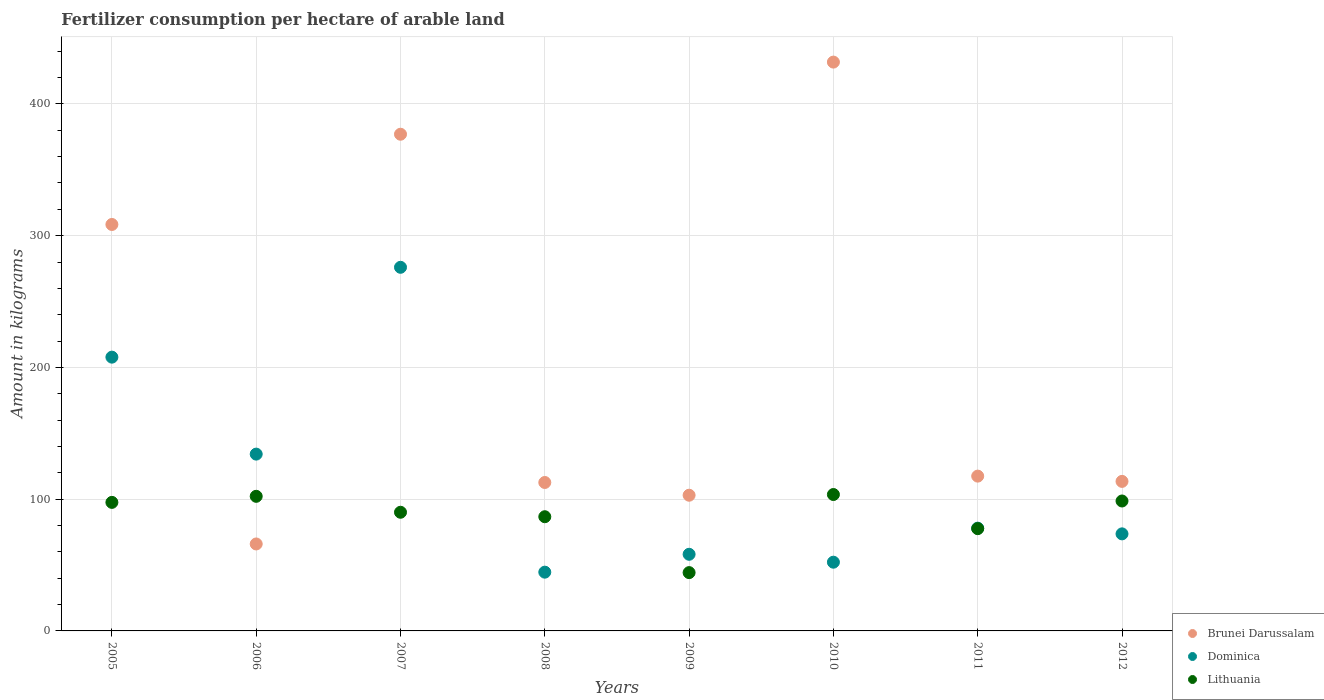How many different coloured dotlines are there?
Your answer should be compact. 3. What is the amount of fertilizer consumption in Lithuania in 2011?
Keep it short and to the point. 77.63. Across all years, what is the maximum amount of fertilizer consumption in Dominica?
Your response must be concise. 276. Across all years, what is the minimum amount of fertilizer consumption in Dominica?
Your answer should be very brief. 44.6. What is the total amount of fertilizer consumption in Brunei Darussalam in the graph?
Offer a terse response. 1629.92. What is the difference between the amount of fertilizer consumption in Brunei Darussalam in 2007 and that in 2011?
Make the answer very short. 259.5. What is the difference between the amount of fertilizer consumption in Lithuania in 2006 and the amount of fertilizer consumption in Brunei Darussalam in 2012?
Provide a succinct answer. -11.33. What is the average amount of fertilizer consumption in Dominica per year?
Give a very brief answer. 115.58. In the year 2006, what is the difference between the amount of fertilizer consumption in Dominica and amount of fertilizer consumption in Lithuania?
Your answer should be very brief. 32.03. What is the ratio of the amount of fertilizer consumption in Lithuania in 2007 to that in 2012?
Make the answer very short. 0.91. Is the difference between the amount of fertilizer consumption in Dominica in 2010 and 2012 greater than the difference between the amount of fertilizer consumption in Lithuania in 2010 and 2012?
Ensure brevity in your answer.  No. What is the difference between the highest and the second highest amount of fertilizer consumption in Dominica?
Ensure brevity in your answer.  68.2. What is the difference between the highest and the lowest amount of fertilizer consumption in Brunei Darussalam?
Ensure brevity in your answer.  365.75. Is the sum of the amount of fertilizer consumption in Lithuania in 2005 and 2009 greater than the maximum amount of fertilizer consumption in Brunei Darussalam across all years?
Offer a terse response. No. Does the amount of fertilizer consumption in Dominica monotonically increase over the years?
Keep it short and to the point. No. Is the amount of fertilizer consumption in Brunei Darussalam strictly less than the amount of fertilizer consumption in Lithuania over the years?
Provide a succinct answer. No. How many years are there in the graph?
Ensure brevity in your answer.  8. What is the difference between two consecutive major ticks on the Y-axis?
Offer a terse response. 100. Are the values on the major ticks of Y-axis written in scientific E-notation?
Keep it short and to the point. No. Does the graph contain any zero values?
Keep it short and to the point. No. Does the graph contain grids?
Give a very brief answer. Yes. Where does the legend appear in the graph?
Keep it short and to the point. Bottom right. How many legend labels are there?
Give a very brief answer. 3. How are the legend labels stacked?
Provide a short and direct response. Vertical. What is the title of the graph?
Offer a terse response. Fertilizer consumption per hectare of arable land. What is the label or title of the Y-axis?
Your response must be concise. Amount in kilograms. What is the Amount in kilograms in Brunei Darussalam in 2005?
Provide a short and direct response. 308.5. What is the Amount in kilograms in Dominica in 2005?
Make the answer very short. 207.8. What is the Amount in kilograms of Lithuania in 2005?
Give a very brief answer. 97.56. What is the Amount in kilograms of Brunei Darussalam in 2006?
Your answer should be compact. 66. What is the Amount in kilograms of Dominica in 2006?
Your answer should be compact. 134.2. What is the Amount in kilograms in Lithuania in 2006?
Keep it short and to the point. 102.17. What is the Amount in kilograms of Brunei Darussalam in 2007?
Your answer should be compact. 377. What is the Amount in kilograms of Dominica in 2007?
Provide a succinct answer. 276. What is the Amount in kilograms of Lithuania in 2007?
Your answer should be very brief. 90.07. What is the Amount in kilograms of Brunei Darussalam in 2008?
Ensure brevity in your answer.  112.67. What is the Amount in kilograms of Dominica in 2008?
Offer a very short reply. 44.6. What is the Amount in kilograms in Lithuania in 2008?
Provide a short and direct response. 86.68. What is the Amount in kilograms in Brunei Darussalam in 2009?
Make the answer very short. 103. What is the Amount in kilograms of Dominica in 2009?
Make the answer very short. 58.17. What is the Amount in kilograms in Lithuania in 2009?
Your answer should be very brief. 44.26. What is the Amount in kilograms of Brunei Darussalam in 2010?
Provide a succinct answer. 431.75. What is the Amount in kilograms in Dominica in 2010?
Your answer should be very brief. 52.17. What is the Amount in kilograms of Lithuania in 2010?
Keep it short and to the point. 103.53. What is the Amount in kilograms of Brunei Darussalam in 2011?
Keep it short and to the point. 117.5. What is the Amount in kilograms of Dominica in 2011?
Your response must be concise. 78. What is the Amount in kilograms of Lithuania in 2011?
Ensure brevity in your answer.  77.63. What is the Amount in kilograms in Brunei Darussalam in 2012?
Give a very brief answer. 113.5. What is the Amount in kilograms of Dominica in 2012?
Your response must be concise. 73.67. What is the Amount in kilograms of Lithuania in 2012?
Give a very brief answer. 98.62. Across all years, what is the maximum Amount in kilograms in Brunei Darussalam?
Offer a very short reply. 431.75. Across all years, what is the maximum Amount in kilograms of Dominica?
Keep it short and to the point. 276. Across all years, what is the maximum Amount in kilograms of Lithuania?
Keep it short and to the point. 103.53. Across all years, what is the minimum Amount in kilograms of Brunei Darussalam?
Provide a short and direct response. 66. Across all years, what is the minimum Amount in kilograms of Dominica?
Your response must be concise. 44.6. Across all years, what is the minimum Amount in kilograms in Lithuania?
Provide a succinct answer. 44.26. What is the total Amount in kilograms of Brunei Darussalam in the graph?
Offer a very short reply. 1629.92. What is the total Amount in kilograms in Dominica in the graph?
Your answer should be very brief. 924.6. What is the total Amount in kilograms in Lithuania in the graph?
Your response must be concise. 700.52. What is the difference between the Amount in kilograms of Brunei Darussalam in 2005 and that in 2006?
Your answer should be very brief. 242.5. What is the difference between the Amount in kilograms of Dominica in 2005 and that in 2006?
Make the answer very short. 73.6. What is the difference between the Amount in kilograms in Lithuania in 2005 and that in 2006?
Your answer should be very brief. -4.6. What is the difference between the Amount in kilograms of Brunei Darussalam in 2005 and that in 2007?
Provide a short and direct response. -68.5. What is the difference between the Amount in kilograms in Dominica in 2005 and that in 2007?
Your response must be concise. -68.2. What is the difference between the Amount in kilograms in Lithuania in 2005 and that in 2007?
Keep it short and to the point. 7.5. What is the difference between the Amount in kilograms in Brunei Darussalam in 2005 and that in 2008?
Provide a succinct answer. 195.83. What is the difference between the Amount in kilograms in Dominica in 2005 and that in 2008?
Your response must be concise. 163.2. What is the difference between the Amount in kilograms of Lithuania in 2005 and that in 2008?
Provide a short and direct response. 10.88. What is the difference between the Amount in kilograms of Brunei Darussalam in 2005 and that in 2009?
Provide a succinct answer. 205.5. What is the difference between the Amount in kilograms of Dominica in 2005 and that in 2009?
Give a very brief answer. 149.63. What is the difference between the Amount in kilograms of Lithuania in 2005 and that in 2009?
Your answer should be compact. 53.31. What is the difference between the Amount in kilograms of Brunei Darussalam in 2005 and that in 2010?
Offer a terse response. -123.25. What is the difference between the Amount in kilograms in Dominica in 2005 and that in 2010?
Your answer should be compact. 155.63. What is the difference between the Amount in kilograms of Lithuania in 2005 and that in 2010?
Offer a very short reply. -5.97. What is the difference between the Amount in kilograms of Brunei Darussalam in 2005 and that in 2011?
Offer a terse response. 191. What is the difference between the Amount in kilograms in Dominica in 2005 and that in 2011?
Provide a short and direct response. 129.8. What is the difference between the Amount in kilograms in Lithuania in 2005 and that in 2011?
Ensure brevity in your answer.  19.93. What is the difference between the Amount in kilograms in Brunei Darussalam in 2005 and that in 2012?
Give a very brief answer. 195. What is the difference between the Amount in kilograms in Dominica in 2005 and that in 2012?
Ensure brevity in your answer.  134.13. What is the difference between the Amount in kilograms in Lithuania in 2005 and that in 2012?
Your answer should be compact. -1.05. What is the difference between the Amount in kilograms in Brunei Darussalam in 2006 and that in 2007?
Your answer should be compact. -311. What is the difference between the Amount in kilograms of Dominica in 2006 and that in 2007?
Provide a succinct answer. -141.8. What is the difference between the Amount in kilograms in Lithuania in 2006 and that in 2007?
Ensure brevity in your answer.  12.1. What is the difference between the Amount in kilograms of Brunei Darussalam in 2006 and that in 2008?
Offer a very short reply. -46.67. What is the difference between the Amount in kilograms in Dominica in 2006 and that in 2008?
Your response must be concise. 89.6. What is the difference between the Amount in kilograms of Lithuania in 2006 and that in 2008?
Your answer should be compact. 15.49. What is the difference between the Amount in kilograms in Brunei Darussalam in 2006 and that in 2009?
Your answer should be very brief. -37. What is the difference between the Amount in kilograms in Dominica in 2006 and that in 2009?
Give a very brief answer. 76.03. What is the difference between the Amount in kilograms of Lithuania in 2006 and that in 2009?
Your answer should be very brief. 57.91. What is the difference between the Amount in kilograms of Brunei Darussalam in 2006 and that in 2010?
Give a very brief answer. -365.75. What is the difference between the Amount in kilograms in Dominica in 2006 and that in 2010?
Give a very brief answer. 82.03. What is the difference between the Amount in kilograms of Lithuania in 2006 and that in 2010?
Your answer should be compact. -1.37. What is the difference between the Amount in kilograms in Brunei Darussalam in 2006 and that in 2011?
Your answer should be compact. -51.5. What is the difference between the Amount in kilograms in Dominica in 2006 and that in 2011?
Your answer should be compact. 56.2. What is the difference between the Amount in kilograms in Lithuania in 2006 and that in 2011?
Give a very brief answer. 24.54. What is the difference between the Amount in kilograms in Brunei Darussalam in 2006 and that in 2012?
Your answer should be very brief. -47.5. What is the difference between the Amount in kilograms in Dominica in 2006 and that in 2012?
Offer a terse response. 60.53. What is the difference between the Amount in kilograms in Lithuania in 2006 and that in 2012?
Offer a very short reply. 3.55. What is the difference between the Amount in kilograms in Brunei Darussalam in 2007 and that in 2008?
Offer a terse response. 264.33. What is the difference between the Amount in kilograms in Dominica in 2007 and that in 2008?
Make the answer very short. 231.4. What is the difference between the Amount in kilograms of Lithuania in 2007 and that in 2008?
Your answer should be very brief. 3.38. What is the difference between the Amount in kilograms in Brunei Darussalam in 2007 and that in 2009?
Ensure brevity in your answer.  274. What is the difference between the Amount in kilograms in Dominica in 2007 and that in 2009?
Keep it short and to the point. 217.83. What is the difference between the Amount in kilograms in Lithuania in 2007 and that in 2009?
Provide a short and direct response. 45.81. What is the difference between the Amount in kilograms in Brunei Darussalam in 2007 and that in 2010?
Your response must be concise. -54.75. What is the difference between the Amount in kilograms of Dominica in 2007 and that in 2010?
Your response must be concise. 223.83. What is the difference between the Amount in kilograms of Lithuania in 2007 and that in 2010?
Your response must be concise. -13.47. What is the difference between the Amount in kilograms of Brunei Darussalam in 2007 and that in 2011?
Your answer should be very brief. 259.5. What is the difference between the Amount in kilograms of Dominica in 2007 and that in 2011?
Make the answer very short. 198. What is the difference between the Amount in kilograms in Lithuania in 2007 and that in 2011?
Make the answer very short. 12.43. What is the difference between the Amount in kilograms in Brunei Darussalam in 2007 and that in 2012?
Make the answer very short. 263.5. What is the difference between the Amount in kilograms in Dominica in 2007 and that in 2012?
Ensure brevity in your answer.  202.33. What is the difference between the Amount in kilograms of Lithuania in 2007 and that in 2012?
Make the answer very short. -8.55. What is the difference between the Amount in kilograms in Brunei Darussalam in 2008 and that in 2009?
Keep it short and to the point. 9.67. What is the difference between the Amount in kilograms in Dominica in 2008 and that in 2009?
Your response must be concise. -13.57. What is the difference between the Amount in kilograms of Lithuania in 2008 and that in 2009?
Your response must be concise. 42.43. What is the difference between the Amount in kilograms of Brunei Darussalam in 2008 and that in 2010?
Keep it short and to the point. -319.08. What is the difference between the Amount in kilograms of Dominica in 2008 and that in 2010?
Offer a very short reply. -7.57. What is the difference between the Amount in kilograms in Lithuania in 2008 and that in 2010?
Ensure brevity in your answer.  -16.85. What is the difference between the Amount in kilograms of Brunei Darussalam in 2008 and that in 2011?
Keep it short and to the point. -4.83. What is the difference between the Amount in kilograms of Dominica in 2008 and that in 2011?
Your response must be concise. -33.4. What is the difference between the Amount in kilograms of Lithuania in 2008 and that in 2011?
Your answer should be compact. 9.05. What is the difference between the Amount in kilograms of Dominica in 2008 and that in 2012?
Make the answer very short. -29.07. What is the difference between the Amount in kilograms in Lithuania in 2008 and that in 2012?
Make the answer very short. -11.94. What is the difference between the Amount in kilograms in Brunei Darussalam in 2009 and that in 2010?
Make the answer very short. -328.75. What is the difference between the Amount in kilograms in Lithuania in 2009 and that in 2010?
Your answer should be very brief. -59.28. What is the difference between the Amount in kilograms in Brunei Darussalam in 2009 and that in 2011?
Your response must be concise. -14.5. What is the difference between the Amount in kilograms of Dominica in 2009 and that in 2011?
Offer a terse response. -19.83. What is the difference between the Amount in kilograms of Lithuania in 2009 and that in 2011?
Provide a short and direct response. -33.38. What is the difference between the Amount in kilograms of Brunei Darussalam in 2009 and that in 2012?
Give a very brief answer. -10.5. What is the difference between the Amount in kilograms in Dominica in 2009 and that in 2012?
Your answer should be very brief. -15.5. What is the difference between the Amount in kilograms in Lithuania in 2009 and that in 2012?
Provide a succinct answer. -54.36. What is the difference between the Amount in kilograms in Brunei Darussalam in 2010 and that in 2011?
Your answer should be very brief. 314.25. What is the difference between the Amount in kilograms of Dominica in 2010 and that in 2011?
Offer a terse response. -25.83. What is the difference between the Amount in kilograms of Lithuania in 2010 and that in 2011?
Offer a terse response. 25.9. What is the difference between the Amount in kilograms of Brunei Darussalam in 2010 and that in 2012?
Your answer should be compact. 318.25. What is the difference between the Amount in kilograms of Dominica in 2010 and that in 2012?
Offer a terse response. -21.5. What is the difference between the Amount in kilograms in Lithuania in 2010 and that in 2012?
Your response must be concise. 4.92. What is the difference between the Amount in kilograms in Dominica in 2011 and that in 2012?
Your response must be concise. 4.33. What is the difference between the Amount in kilograms of Lithuania in 2011 and that in 2012?
Your answer should be compact. -20.98. What is the difference between the Amount in kilograms in Brunei Darussalam in 2005 and the Amount in kilograms in Dominica in 2006?
Your response must be concise. 174.3. What is the difference between the Amount in kilograms of Brunei Darussalam in 2005 and the Amount in kilograms of Lithuania in 2006?
Provide a short and direct response. 206.33. What is the difference between the Amount in kilograms in Dominica in 2005 and the Amount in kilograms in Lithuania in 2006?
Make the answer very short. 105.63. What is the difference between the Amount in kilograms in Brunei Darussalam in 2005 and the Amount in kilograms in Dominica in 2007?
Offer a terse response. 32.5. What is the difference between the Amount in kilograms in Brunei Darussalam in 2005 and the Amount in kilograms in Lithuania in 2007?
Your answer should be very brief. 218.43. What is the difference between the Amount in kilograms in Dominica in 2005 and the Amount in kilograms in Lithuania in 2007?
Your answer should be compact. 117.73. What is the difference between the Amount in kilograms in Brunei Darussalam in 2005 and the Amount in kilograms in Dominica in 2008?
Give a very brief answer. 263.9. What is the difference between the Amount in kilograms of Brunei Darussalam in 2005 and the Amount in kilograms of Lithuania in 2008?
Your response must be concise. 221.82. What is the difference between the Amount in kilograms in Dominica in 2005 and the Amount in kilograms in Lithuania in 2008?
Your response must be concise. 121.12. What is the difference between the Amount in kilograms of Brunei Darussalam in 2005 and the Amount in kilograms of Dominica in 2009?
Keep it short and to the point. 250.33. What is the difference between the Amount in kilograms of Brunei Darussalam in 2005 and the Amount in kilograms of Lithuania in 2009?
Ensure brevity in your answer.  264.24. What is the difference between the Amount in kilograms in Dominica in 2005 and the Amount in kilograms in Lithuania in 2009?
Your answer should be compact. 163.54. What is the difference between the Amount in kilograms in Brunei Darussalam in 2005 and the Amount in kilograms in Dominica in 2010?
Your response must be concise. 256.33. What is the difference between the Amount in kilograms in Brunei Darussalam in 2005 and the Amount in kilograms in Lithuania in 2010?
Your answer should be compact. 204.97. What is the difference between the Amount in kilograms of Dominica in 2005 and the Amount in kilograms of Lithuania in 2010?
Your response must be concise. 104.27. What is the difference between the Amount in kilograms of Brunei Darussalam in 2005 and the Amount in kilograms of Dominica in 2011?
Your answer should be compact. 230.5. What is the difference between the Amount in kilograms of Brunei Darussalam in 2005 and the Amount in kilograms of Lithuania in 2011?
Ensure brevity in your answer.  230.87. What is the difference between the Amount in kilograms in Dominica in 2005 and the Amount in kilograms in Lithuania in 2011?
Your answer should be very brief. 130.17. What is the difference between the Amount in kilograms of Brunei Darussalam in 2005 and the Amount in kilograms of Dominica in 2012?
Provide a short and direct response. 234.83. What is the difference between the Amount in kilograms of Brunei Darussalam in 2005 and the Amount in kilograms of Lithuania in 2012?
Provide a short and direct response. 209.88. What is the difference between the Amount in kilograms in Dominica in 2005 and the Amount in kilograms in Lithuania in 2012?
Offer a very short reply. 109.18. What is the difference between the Amount in kilograms of Brunei Darussalam in 2006 and the Amount in kilograms of Dominica in 2007?
Keep it short and to the point. -210. What is the difference between the Amount in kilograms of Brunei Darussalam in 2006 and the Amount in kilograms of Lithuania in 2007?
Offer a very short reply. -24.07. What is the difference between the Amount in kilograms in Dominica in 2006 and the Amount in kilograms in Lithuania in 2007?
Offer a terse response. 44.13. What is the difference between the Amount in kilograms in Brunei Darussalam in 2006 and the Amount in kilograms in Dominica in 2008?
Provide a short and direct response. 21.4. What is the difference between the Amount in kilograms of Brunei Darussalam in 2006 and the Amount in kilograms of Lithuania in 2008?
Offer a terse response. -20.68. What is the difference between the Amount in kilograms in Dominica in 2006 and the Amount in kilograms in Lithuania in 2008?
Provide a short and direct response. 47.52. What is the difference between the Amount in kilograms of Brunei Darussalam in 2006 and the Amount in kilograms of Dominica in 2009?
Keep it short and to the point. 7.83. What is the difference between the Amount in kilograms in Brunei Darussalam in 2006 and the Amount in kilograms in Lithuania in 2009?
Give a very brief answer. 21.74. What is the difference between the Amount in kilograms of Dominica in 2006 and the Amount in kilograms of Lithuania in 2009?
Give a very brief answer. 89.94. What is the difference between the Amount in kilograms in Brunei Darussalam in 2006 and the Amount in kilograms in Dominica in 2010?
Keep it short and to the point. 13.83. What is the difference between the Amount in kilograms of Brunei Darussalam in 2006 and the Amount in kilograms of Lithuania in 2010?
Give a very brief answer. -37.53. What is the difference between the Amount in kilograms in Dominica in 2006 and the Amount in kilograms in Lithuania in 2010?
Your answer should be very brief. 30.67. What is the difference between the Amount in kilograms of Brunei Darussalam in 2006 and the Amount in kilograms of Lithuania in 2011?
Your answer should be compact. -11.63. What is the difference between the Amount in kilograms of Dominica in 2006 and the Amount in kilograms of Lithuania in 2011?
Provide a short and direct response. 56.57. What is the difference between the Amount in kilograms of Brunei Darussalam in 2006 and the Amount in kilograms of Dominica in 2012?
Provide a short and direct response. -7.67. What is the difference between the Amount in kilograms of Brunei Darussalam in 2006 and the Amount in kilograms of Lithuania in 2012?
Your answer should be compact. -32.62. What is the difference between the Amount in kilograms in Dominica in 2006 and the Amount in kilograms in Lithuania in 2012?
Make the answer very short. 35.58. What is the difference between the Amount in kilograms of Brunei Darussalam in 2007 and the Amount in kilograms of Dominica in 2008?
Provide a succinct answer. 332.4. What is the difference between the Amount in kilograms of Brunei Darussalam in 2007 and the Amount in kilograms of Lithuania in 2008?
Your response must be concise. 290.32. What is the difference between the Amount in kilograms in Dominica in 2007 and the Amount in kilograms in Lithuania in 2008?
Offer a very short reply. 189.32. What is the difference between the Amount in kilograms of Brunei Darussalam in 2007 and the Amount in kilograms of Dominica in 2009?
Ensure brevity in your answer.  318.83. What is the difference between the Amount in kilograms in Brunei Darussalam in 2007 and the Amount in kilograms in Lithuania in 2009?
Give a very brief answer. 332.74. What is the difference between the Amount in kilograms in Dominica in 2007 and the Amount in kilograms in Lithuania in 2009?
Your answer should be very brief. 231.74. What is the difference between the Amount in kilograms in Brunei Darussalam in 2007 and the Amount in kilograms in Dominica in 2010?
Your response must be concise. 324.83. What is the difference between the Amount in kilograms of Brunei Darussalam in 2007 and the Amount in kilograms of Lithuania in 2010?
Offer a very short reply. 273.47. What is the difference between the Amount in kilograms in Dominica in 2007 and the Amount in kilograms in Lithuania in 2010?
Offer a terse response. 172.47. What is the difference between the Amount in kilograms in Brunei Darussalam in 2007 and the Amount in kilograms in Dominica in 2011?
Your answer should be very brief. 299. What is the difference between the Amount in kilograms of Brunei Darussalam in 2007 and the Amount in kilograms of Lithuania in 2011?
Provide a short and direct response. 299.37. What is the difference between the Amount in kilograms in Dominica in 2007 and the Amount in kilograms in Lithuania in 2011?
Make the answer very short. 198.37. What is the difference between the Amount in kilograms in Brunei Darussalam in 2007 and the Amount in kilograms in Dominica in 2012?
Give a very brief answer. 303.33. What is the difference between the Amount in kilograms in Brunei Darussalam in 2007 and the Amount in kilograms in Lithuania in 2012?
Ensure brevity in your answer.  278.38. What is the difference between the Amount in kilograms in Dominica in 2007 and the Amount in kilograms in Lithuania in 2012?
Provide a short and direct response. 177.38. What is the difference between the Amount in kilograms of Brunei Darussalam in 2008 and the Amount in kilograms of Dominica in 2009?
Offer a very short reply. 54.5. What is the difference between the Amount in kilograms of Brunei Darussalam in 2008 and the Amount in kilograms of Lithuania in 2009?
Provide a succinct answer. 68.41. What is the difference between the Amount in kilograms of Dominica in 2008 and the Amount in kilograms of Lithuania in 2009?
Your answer should be compact. 0.34. What is the difference between the Amount in kilograms of Brunei Darussalam in 2008 and the Amount in kilograms of Dominica in 2010?
Your answer should be very brief. 60.5. What is the difference between the Amount in kilograms of Brunei Darussalam in 2008 and the Amount in kilograms of Lithuania in 2010?
Your answer should be very brief. 9.13. What is the difference between the Amount in kilograms of Dominica in 2008 and the Amount in kilograms of Lithuania in 2010?
Your response must be concise. -58.93. What is the difference between the Amount in kilograms in Brunei Darussalam in 2008 and the Amount in kilograms in Dominica in 2011?
Your answer should be very brief. 34.67. What is the difference between the Amount in kilograms of Brunei Darussalam in 2008 and the Amount in kilograms of Lithuania in 2011?
Offer a terse response. 35.03. What is the difference between the Amount in kilograms of Dominica in 2008 and the Amount in kilograms of Lithuania in 2011?
Ensure brevity in your answer.  -33.03. What is the difference between the Amount in kilograms of Brunei Darussalam in 2008 and the Amount in kilograms of Lithuania in 2012?
Make the answer very short. 14.05. What is the difference between the Amount in kilograms in Dominica in 2008 and the Amount in kilograms in Lithuania in 2012?
Offer a very short reply. -54.02. What is the difference between the Amount in kilograms in Brunei Darussalam in 2009 and the Amount in kilograms in Dominica in 2010?
Ensure brevity in your answer.  50.83. What is the difference between the Amount in kilograms in Brunei Darussalam in 2009 and the Amount in kilograms in Lithuania in 2010?
Your answer should be very brief. -0.53. What is the difference between the Amount in kilograms of Dominica in 2009 and the Amount in kilograms of Lithuania in 2010?
Provide a short and direct response. -45.37. What is the difference between the Amount in kilograms in Brunei Darussalam in 2009 and the Amount in kilograms in Lithuania in 2011?
Keep it short and to the point. 25.37. What is the difference between the Amount in kilograms of Dominica in 2009 and the Amount in kilograms of Lithuania in 2011?
Keep it short and to the point. -19.47. What is the difference between the Amount in kilograms of Brunei Darussalam in 2009 and the Amount in kilograms of Dominica in 2012?
Offer a terse response. 29.33. What is the difference between the Amount in kilograms in Brunei Darussalam in 2009 and the Amount in kilograms in Lithuania in 2012?
Your answer should be very brief. 4.38. What is the difference between the Amount in kilograms of Dominica in 2009 and the Amount in kilograms of Lithuania in 2012?
Make the answer very short. -40.45. What is the difference between the Amount in kilograms of Brunei Darussalam in 2010 and the Amount in kilograms of Dominica in 2011?
Ensure brevity in your answer.  353.75. What is the difference between the Amount in kilograms of Brunei Darussalam in 2010 and the Amount in kilograms of Lithuania in 2011?
Provide a succinct answer. 354.12. What is the difference between the Amount in kilograms of Dominica in 2010 and the Amount in kilograms of Lithuania in 2011?
Your answer should be compact. -25.47. What is the difference between the Amount in kilograms of Brunei Darussalam in 2010 and the Amount in kilograms of Dominica in 2012?
Provide a succinct answer. 358.08. What is the difference between the Amount in kilograms in Brunei Darussalam in 2010 and the Amount in kilograms in Lithuania in 2012?
Make the answer very short. 333.13. What is the difference between the Amount in kilograms of Dominica in 2010 and the Amount in kilograms of Lithuania in 2012?
Offer a very short reply. -46.45. What is the difference between the Amount in kilograms of Brunei Darussalam in 2011 and the Amount in kilograms of Dominica in 2012?
Provide a short and direct response. 43.83. What is the difference between the Amount in kilograms of Brunei Darussalam in 2011 and the Amount in kilograms of Lithuania in 2012?
Your response must be concise. 18.88. What is the difference between the Amount in kilograms in Dominica in 2011 and the Amount in kilograms in Lithuania in 2012?
Your response must be concise. -20.62. What is the average Amount in kilograms of Brunei Darussalam per year?
Your answer should be compact. 203.74. What is the average Amount in kilograms in Dominica per year?
Make the answer very short. 115.58. What is the average Amount in kilograms in Lithuania per year?
Your response must be concise. 87.56. In the year 2005, what is the difference between the Amount in kilograms in Brunei Darussalam and Amount in kilograms in Dominica?
Ensure brevity in your answer.  100.7. In the year 2005, what is the difference between the Amount in kilograms of Brunei Darussalam and Amount in kilograms of Lithuania?
Give a very brief answer. 210.94. In the year 2005, what is the difference between the Amount in kilograms of Dominica and Amount in kilograms of Lithuania?
Make the answer very short. 110.24. In the year 2006, what is the difference between the Amount in kilograms in Brunei Darussalam and Amount in kilograms in Dominica?
Offer a terse response. -68.2. In the year 2006, what is the difference between the Amount in kilograms of Brunei Darussalam and Amount in kilograms of Lithuania?
Your response must be concise. -36.17. In the year 2006, what is the difference between the Amount in kilograms of Dominica and Amount in kilograms of Lithuania?
Make the answer very short. 32.03. In the year 2007, what is the difference between the Amount in kilograms in Brunei Darussalam and Amount in kilograms in Dominica?
Provide a short and direct response. 101. In the year 2007, what is the difference between the Amount in kilograms of Brunei Darussalam and Amount in kilograms of Lithuania?
Make the answer very short. 286.93. In the year 2007, what is the difference between the Amount in kilograms in Dominica and Amount in kilograms in Lithuania?
Offer a terse response. 185.93. In the year 2008, what is the difference between the Amount in kilograms of Brunei Darussalam and Amount in kilograms of Dominica?
Your answer should be very brief. 68.07. In the year 2008, what is the difference between the Amount in kilograms in Brunei Darussalam and Amount in kilograms in Lithuania?
Your answer should be compact. 25.99. In the year 2008, what is the difference between the Amount in kilograms of Dominica and Amount in kilograms of Lithuania?
Your answer should be compact. -42.08. In the year 2009, what is the difference between the Amount in kilograms in Brunei Darussalam and Amount in kilograms in Dominica?
Your answer should be compact. 44.83. In the year 2009, what is the difference between the Amount in kilograms in Brunei Darussalam and Amount in kilograms in Lithuania?
Make the answer very short. 58.74. In the year 2009, what is the difference between the Amount in kilograms of Dominica and Amount in kilograms of Lithuania?
Offer a terse response. 13.91. In the year 2010, what is the difference between the Amount in kilograms in Brunei Darussalam and Amount in kilograms in Dominica?
Give a very brief answer. 379.58. In the year 2010, what is the difference between the Amount in kilograms in Brunei Darussalam and Amount in kilograms in Lithuania?
Provide a succinct answer. 328.22. In the year 2010, what is the difference between the Amount in kilograms in Dominica and Amount in kilograms in Lithuania?
Your response must be concise. -51.37. In the year 2011, what is the difference between the Amount in kilograms of Brunei Darussalam and Amount in kilograms of Dominica?
Ensure brevity in your answer.  39.5. In the year 2011, what is the difference between the Amount in kilograms in Brunei Darussalam and Amount in kilograms in Lithuania?
Offer a very short reply. 39.87. In the year 2011, what is the difference between the Amount in kilograms in Dominica and Amount in kilograms in Lithuania?
Keep it short and to the point. 0.37. In the year 2012, what is the difference between the Amount in kilograms of Brunei Darussalam and Amount in kilograms of Dominica?
Keep it short and to the point. 39.83. In the year 2012, what is the difference between the Amount in kilograms of Brunei Darussalam and Amount in kilograms of Lithuania?
Provide a short and direct response. 14.88. In the year 2012, what is the difference between the Amount in kilograms in Dominica and Amount in kilograms in Lithuania?
Your response must be concise. -24.95. What is the ratio of the Amount in kilograms of Brunei Darussalam in 2005 to that in 2006?
Provide a succinct answer. 4.67. What is the ratio of the Amount in kilograms of Dominica in 2005 to that in 2006?
Make the answer very short. 1.55. What is the ratio of the Amount in kilograms in Lithuania in 2005 to that in 2006?
Keep it short and to the point. 0.95. What is the ratio of the Amount in kilograms of Brunei Darussalam in 2005 to that in 2007?
Your answer should be very brief. 0.82. What is the ratio of the Amount in kilograms of Dominica in 2005 to that in 2007?
Make the answer very short. 0.75. What is the ratio of the Amount in kilograms of Brunei Darussalam in 2005 to that in 2008?
Offer a very short reply. 2.74. What is the ratio of the Amount in kilograms of Dominica in 2005 to that in 2008?
Ensure brevity in your answer.  4.66. What is the ratio of the Amount in kilograms in Lithuania in 2005 to that in 2008?
Your response must be concise. 1.13. What is the ratio of the Amount in kilograms in Brunei Darussalam in 2005 to that in 2009?
Provide a short and direct response. 3. What is the ratio of the Amount in kilograms of Dominica in 2005 to that in 2009?
Give a very brief answer. 3.57. What is the ratio of the Amount in kilograms of Lithuania in 2005 to that in 2009?
Make the answer very short. 2.2. What is the ratio of the Amount in kilograms in Brunei Darussalam in 2005 to that in 2010?
Your answer should be compact. 0.71. What is the ratio of the Amount in kilograms of Dominica in 2005 to that in 2010?
Your response must be concise. 3.98. What is the ratio of the Amount in kilograms of Lithuania in 2005 to that in 2010?
Keep it short and to the point. 0.94. What is the ratio of the Amount in kilograms in Brunei Darussalam in 2005 to that in 2011?
Your answer should be compact. 2.63. What is the ratio of the Amount in kilograms of Dominica in 2005 to that in 2011?
Offer a very short reply. 2.66. What is the ratio of the Amount in kilograms of Lithuania in 2005 to that in 2011?
Offer a terse response. 1.26. What is the ratio of the Amount in kilograms in Brunei Darussalam in 2005 to that in 2012?
Provide a short and direct response. 2.72. What is the ratio of the Amount in kilograms in Dominica in 2005 to that in 2012?
Your answer should be very brief. 2.82. What is the ratio of the Amount in kilograms in Lithuania in 2005 to that in 2012?
Your answer should be compact. 0.99. What is the ratio of the Amount in kilograms in Brunei Darussalam in 2006 to that in 2007?
Your response must be concise. 0.18. What is the ratio of the Amount in kilograms of Dominica in 2006 to that in 2007?
Make the answer very short. 0.49. What is the ratio of the Amount in kilograms in Lithuania in 2006 to that in 2007?
Keep it short and to the point. 1.13. What is the ratio of the Amount in kilograms of Brunei Darussalam in 2006 to that in 2008?
Keep it short and to the point. 0.59. What is the ratio of the Amount in kilograms in Dominica in 2006 to that in 2008?
Provide a short and direct response. 3.01. What is the ratio of the Amount in kilograms in Lithuania in 2006 to that in 2008?
Provide a succinct answer. 1.18. What is the ratio of the Amount in kilograms of Brunei Darussalam in 2006 to that in 2009?
Give a very brief answer. 0.64. What is the ratio of the Amount in kilograms in Dominica in 2006 to that in 2009?
Ensure brevity in your answer.  2.31. What is the ratio of the Amount in kilograms in Lithuania in 2006 to that in 2009?
Give a very brief answer. 2.31. What is the ratio of the Amount in kilograms in Brunei Darussalam in 2006 to that in 2010?
Give a very brief answer. 0.15. What is the ratio of the Amount in kilograms in Dominica in 2006 to that in 2010?
Provide a short and direct response. 2.57. What is the ratio of the Amount in kilograms in Brunei Darussalam in 2006 to that in 2011?
Provide a short and direct response. 0.56. What is the ratio of the Amount in kilograms in Dominica in 2006 to that in 2011?
Keep it short and to the point. 1.72. What is the ratio of the Amount in kilograms of Lithuania in 2006 to that in 2011?
Offer a very short reply. 1.32. What is the ratio of the Amount in kilograms in Brunei Darussalam in 2006 to that in 2012?
Your answer should be very brief. 0.58. What is the ratio of the Amount in kilograms in Dominica in 2006 to that in 2012?
Give a very brief answer. 1.82. What is the ratio of the Amount in kilograms of Lithuania in 2006 to that in 2012?
Keep it short and to the point. 1.04. What is the ratio of the Amount in kilograms of Brunei Darussalam in 2007 to that in 2008?
Offer a terse response. 3.35. What is the ratio of the Amount in kilograms in Dominica in 2007 to that in 2008?
Give a very brief answer. 6.19. What is the ratio of the Amount in kilograms in Lithuania in 2007 to that in 2008?
Provide a short and direct response. 1.04. What is the ratio of the Amount in kilograms in Brunei Darussalam in 2007 to that in 2009?
Keep it short and to the point. 3.66. What is the ratio of the Amount in kilograms in Dominica in 2007 to that in 2009?
Keep it short and to the point. 4.75. What is the ratio of the Amount in kilograms of Lithuania in 2007 to that in 2009?
Make the answer very short. 2.04. What is the ratio of the Amount in kilograms in Brunei Darussalam in 2007 to that in 2010?
Your answer should be very brief. 0.87. What is the ratio of the Amount in kilograms of Dominica in 2007 to that in 2010?
Offer a terse response. 5.29. What is the ratio of the Amount in kilograms in Lithuania in 2007 to that in 2010?
Ensure brevity in your answer.  0.87. What is the ratio of the Amount in kilograms in Brunei Darussalam in 2007 to that in 2011?
Your answer should be very brief. 3.21. What is the ratio of the Amount in kilograms in Dominica in 2007 to that in 2011?
Offer a terse response. 3.54. What is the ratio of the Amount in kilograms of Lithuania in 2007 to that in 2011?
Provide a succinct answer. 1.16. What is the ratio of the Amount in kilograms in Brunei Darussalam in 2007 to that in 2012?
Your answer should be very brief. 3.32. What is the ratio of the Amount in kilograms of Dominica in 2007 to that in 2012?
Your response must be concise. 3.75. What is the ratio of the Amount in kilograms of Lithuania in 2007 to that in 2012?
Your answer should be very brief. 0.91. What is the ratio of the Amount in kilograms in Brunei Darussalam in 2008 to that in 2009?
Ensure brevity in your answer.  1.09. What is the ratio of the Amount in kilograms in Dominica in 2008 to that in 2009?
Your answer should be compact. 0.77. What is the ratio of the Amount in kilograms in Lithuania in 2008 to that in 2009?
Your answer should be compact. 1.96. What is the ratio of the Amount in kilograms in Brunei Darussalam in 2008 to that in 2010?
Your answer should be very brief. 0.26. What is the ratio of the Amount in kilograms of Dominica in 2008 to that in 2010?
Give a very brief answer. 0.85. What is the ratio of the Amount in kilograms of Lithuania in 2008 to that in 2010?
Provide a succinct answer. 0.84. What is the ratio of the Amount in kilograms of Brunei Darussalam in 2008 to that in 2011?
Keep it short and to the point. 0.96. What is the ratio of the Amount in kilograms of Dominica in 2008 to that in 2011?
Your response must be concise. 0.57. What is the ratio of the Amount in kilograms of Lithuania in 2008 to that in 2011?
Ensure brevity in your answer.  1.12. What is the ratio of the Amount in kilograms in Dominica in 2008 to that in 2012?
Offer a terse response. 0.61. What is the ratio of the Amount in kilograms in Lithuania in 2008 to that in 2012?
Ensure brevity in your answer.  0.88. What is the ratio of the Amount in kilograms of Brunei Darussalam in 2009 to that in 2010?
Keep it short and to the point. 0.24. What is the ratio of the Amount in kilograms in Dominica in 2009 to that in 2010?
Give a very brief answer. 1.11. What is the ratio of the Amount in kilograms of Lithuania in 2009 to that in 2010?
Provide a short and direct response. 0.43. What is the ratio of the Amount in kilograms of Brunei Darussalam in 2009 to that in 2011?
Your response must be concise. 0.88. What is the ratio of the Amount in kilograms of Dominica in 2009 to that in 2011?
Make the answer very short. 0.75. What is the ratio of the Amount in kilograms of Lithuania in 2009 to that in 2011?
Your answer should be compact. 0.57. What is the ratio of the Amount in kilograms in Brunei Darussalam in 2009 to that in 2012?
Offer a terse response. 0.91. What is the ratio of the Amount in kilograms in Dominica in 2009 to that in 2012?
Provide a succinct answer. 0.79. What is the ratio of the Amount in kilograms in Lithuania in 2009 to that in 2012?
Make the answer very short. 0.45. What is the ratio of the Amount in kilograms in Brunei Darussalam in 2010 to that in 2011?
Offer a terse response. 3.67. What is the ratio of the Amount in kilograms in Dominica in 2010 to that in 2011?
Provide a short and direct response. 0.67. What is the ratio of the Amount in kilograms in Lithuania in 2010 to that in 2011?
Your answer should be very brief. 1.33. What is the ratio of the Amount in kilograms of Brunei Darussalam in 2010 to that in 2012?
Ensure brevity in your answer.  3.8. What is the ratio of the Amount in kilograms in Dominica in 2010 to that in 2012?
Ensure brevity in your answer.  0.71. What is the ratio of the Amount in kilograms of Lithuania in 2010 to that in 2012?
Provide a short and direct response. 1.05. What is the ratio of the Amount in kilograms in Brunei Darussalam in 2011 to that in 2012?
Give a very brief answer. 1.04. What is the ratio of the Amount in kilograms in Dominica in 2011 to that in 2012?
Your answer should be very brief. 1.06. What is the ratio of the Amount in kilograms in Lithuania in 2011 to that in 2012?
Ensure brevity in your answer.  0.79. What is the difference between the highest and the second highest Amount in kilograms in Brunei Darussalam?
Offer a very short reply. 54.75. What is the difference between the highest and the second highest Amount in kilograms in Dominica?
Give a very brief answer. 68.2. What is the difference between the highest and the second highest Amount in kilograms of Lithuania?
Make the answer very short. 1.37. What is the difference between the highest and the lowest Amount in kilograms of Brunei Darussalam?
Your response must be concise. 365.75. What is the difference between the highest and the lowest Amount in kilograms of Dominica?
Keep it short and to the point. 231.4. What is the difference between the highest and the lowest Amount in kilograms of Lithuania?
Provide a succinct answer. 59.28. 